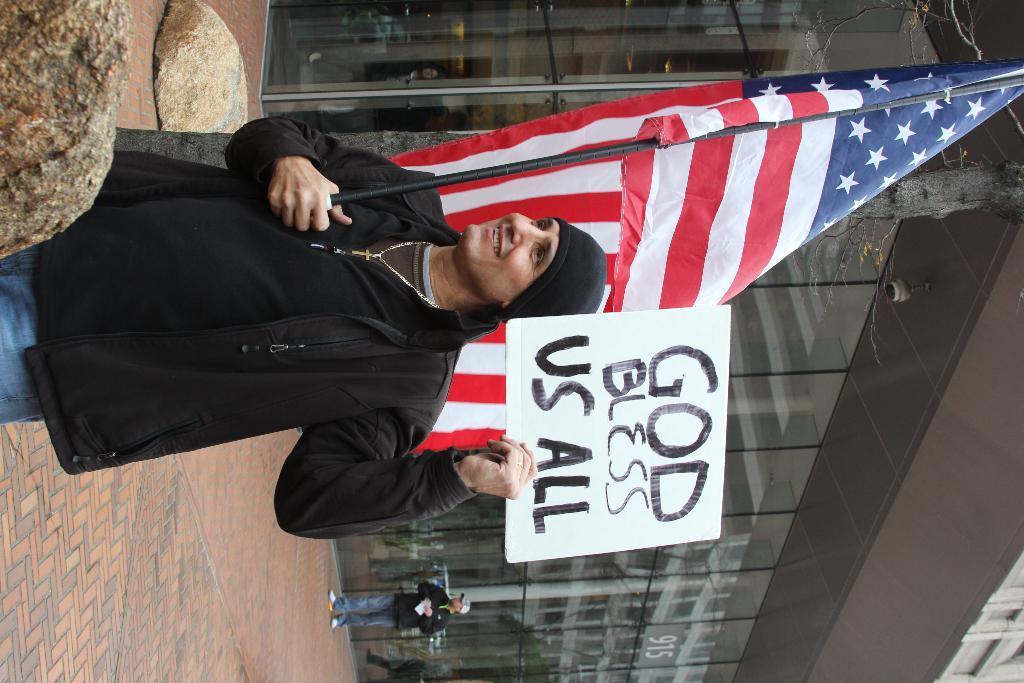Please provide a concise description of this image. In this picture we can see a person, he is holding a flag, poster with his hands, here we can see some stones and in the background we can see people, building on the ground. 